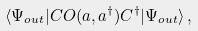<formula> <loc_0><loc_0><loc_500><loc_500>\langle \Psi _ { o u t } | C O ( a , a ^ { \dagger } ) C ^ { \dagger } | \Psi _ { o u t } \rangle \, ,</formula> 